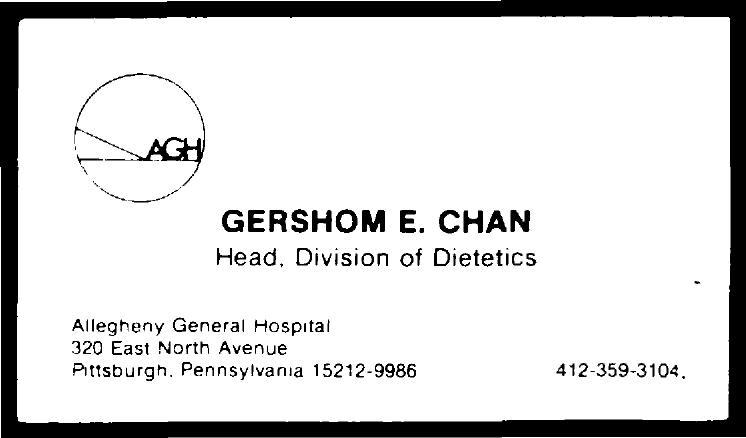Who is the head of the division of dietetics?
Provide a succinct answer. Gershom e. chan. Which text is inside the circle?
Provide a short and direct response. AGH. Which number is at the bottom right of the document??
Make the answer very short. 412-359-3104. 